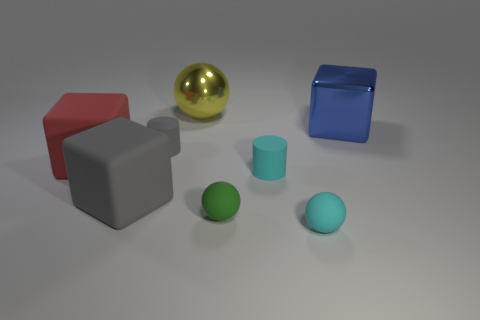Add 2 yellow metal spheres. How many objects exist? 10 Subtract all blocks. How many objects are left? 5 Subtract all gray blocks. Subtract all gray objects. How many objects are left? 5 Add 1 gray rubber cubes. How many gray rubber cubes are left? 2 Add 6 gray objects. How many gray objects exist? 8 Subtract 1 green balls. How many objects are left? 7 